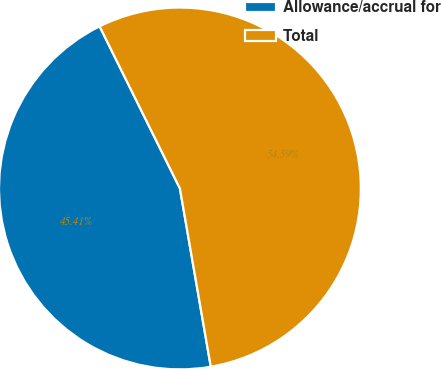Convert chart. <chart><loc_0><loc_0><loc_500><loc_500><pie_chart><fcel>Allowance/accrual for<fcel>Total<nl><fcel>45.41%<fcel>54.59%<nl></chart> 